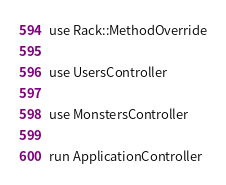<code> <loc_0><loc_0><loc_500><loc_500><_Ruby_>
use Rack::MethodOverride

use UsersController

use MonstersController

run ApplicationController


</code> 